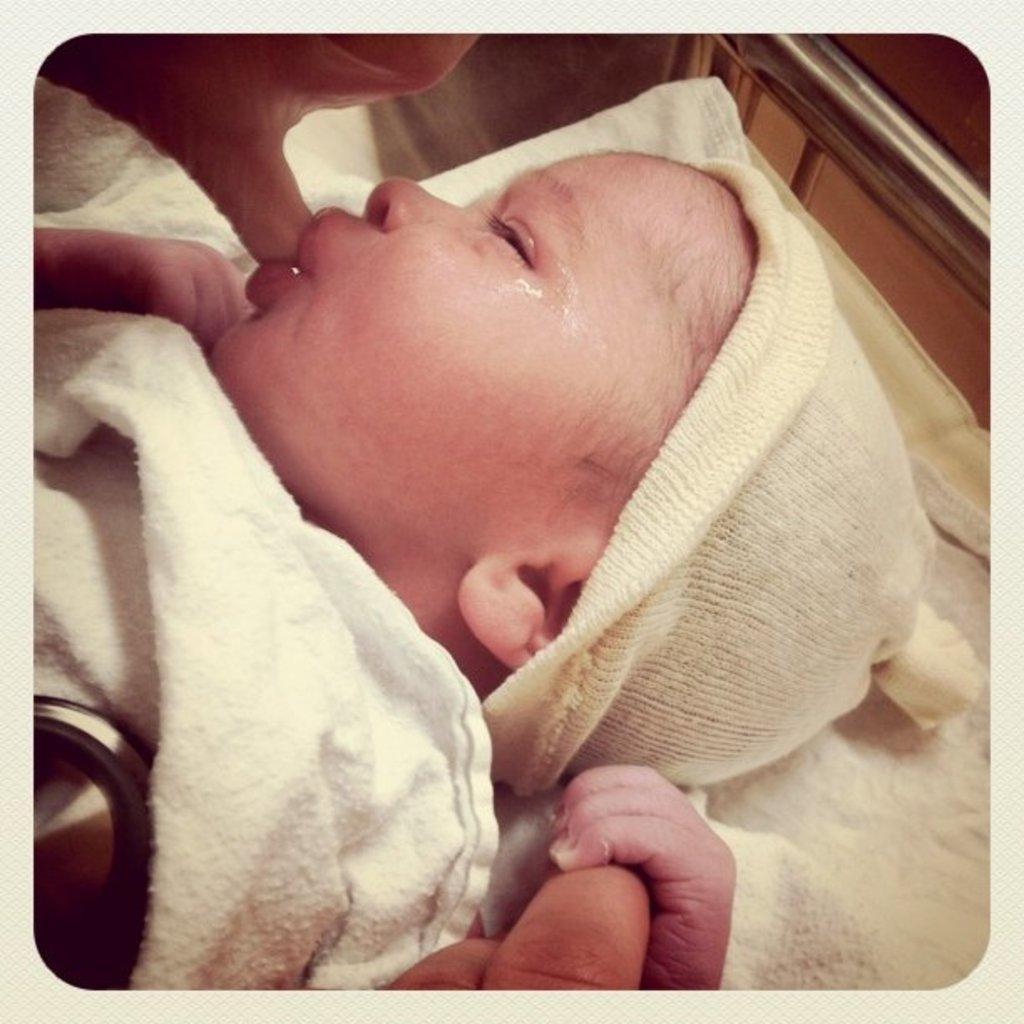In one or two sentences, can you explain what this image depicts? In this picture there is a baby wrapped in cloth. At the top there is a person hand. At the bottom there is a person's hand. On the right there is steel bar. 